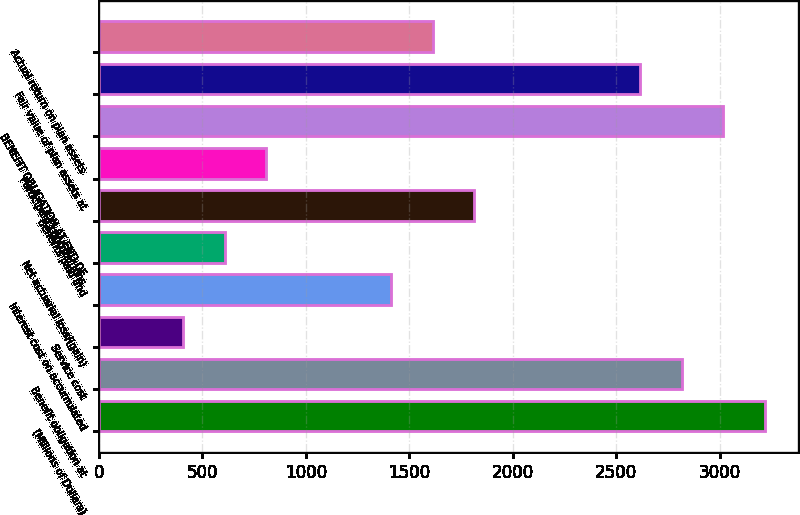Convert chart to OTSL. <chart><loc_0><loc_0><loc_500><loc_500><bar_chart><fcel>(Millions of Dollars)<fcel>Benefit obligation at<fcel>Service cost<fcel>Interest cost on accumulated<fcel>Net actuarial loss/(gain)<fcel>Benefits paid and<fcel>Participant contributions<fcel>BENEFIT OBLIGATION AT END OF<fcel>Fair value of plan assets at<fcel>Actual return on plan assets<nl><fcel>3218.2<fcel>2816.8<fcel>408.4<fcel>1411.9<fcel>609.1<fcel>1813.3<fcel>809.8<fcel>3017.5<fcel>2616.1<fcel>1612.6<nl></chart> 